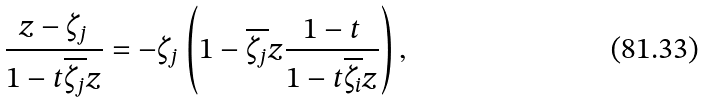<formula> <loc_0><loc_0><loc_500><loc_500>\frac { z - \zeta _ { j } } { 1 - t \overline { \zeta _ { j } } z } = - \zeta _ { j } \left ( 1 - \overline { \zeta _ { j } } z \frac { 1 - t } { 1 - t \overline { \zeta _ { i } } z } \right ) ,</formula> 